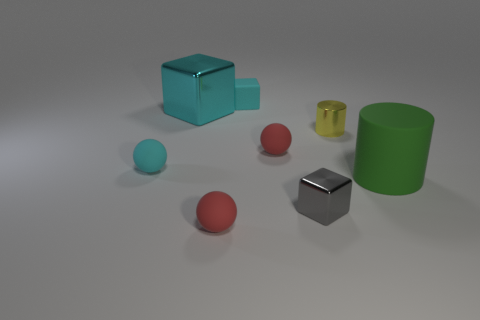Subtract all red matte spheres. How many spheres are left? 1 Subtract all cyan blocks. How many blocks are left? 1 Add 1 big cyan rubber objects. How many objects exist? 9 Subtract all cylinders. How many objects are left? 6 Subtract 2 cylinders. How many cylinders are left? 0 Subtract 0 yellow balls. How many objects are left? 8 Subtract all purple balls. Subtract all brown cylinders. How many balls are left? 3 Subtract all cyan blocks. How many gray cylinders are left? 0 Subtract all small yellow rubber things. Subtract all small red spheres. How many objects are left? 6 Add 8 big green objects. How many big green objects are left? 9 